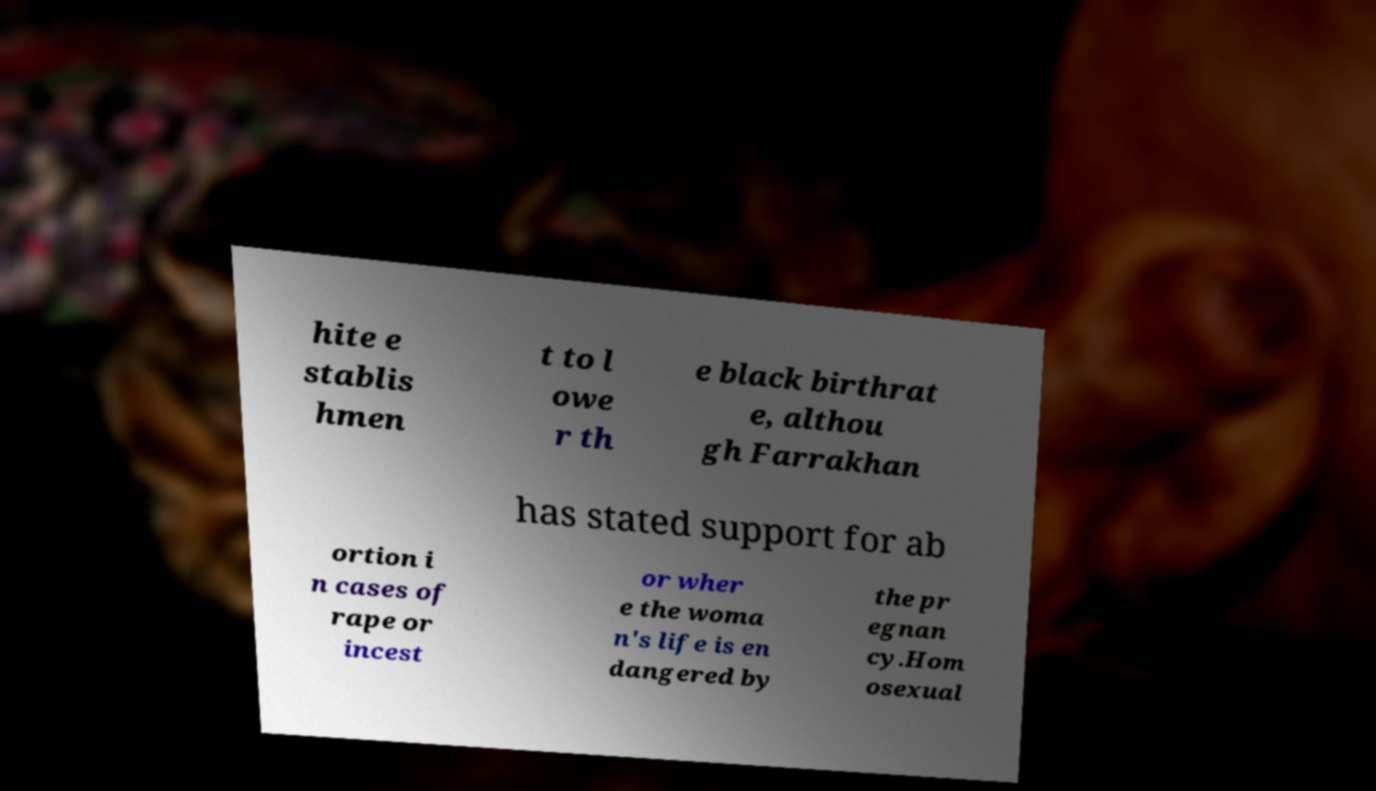There's text embedded in this image that I need extracted. Can you transcribe it verbatim? hite e stablis hmen t to l owe r th e black birthrat e, althou gh Farrakhan has stated support for ab ortion i n cases of rape or incest or wher e the woma n's life is en dangered by the pr egnan cy.Hom osexual 